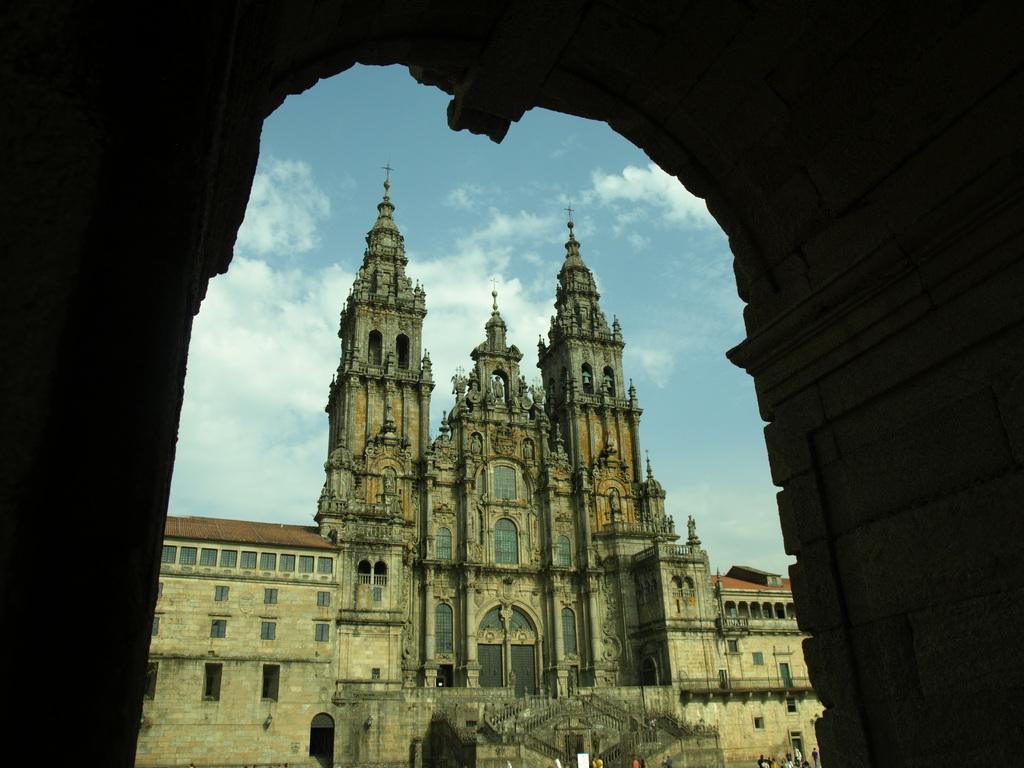Please provide a concise description of this image. In this image there is a building in the background. In the foreground there is an entrance. The sky is cloudy. There are few people here. 